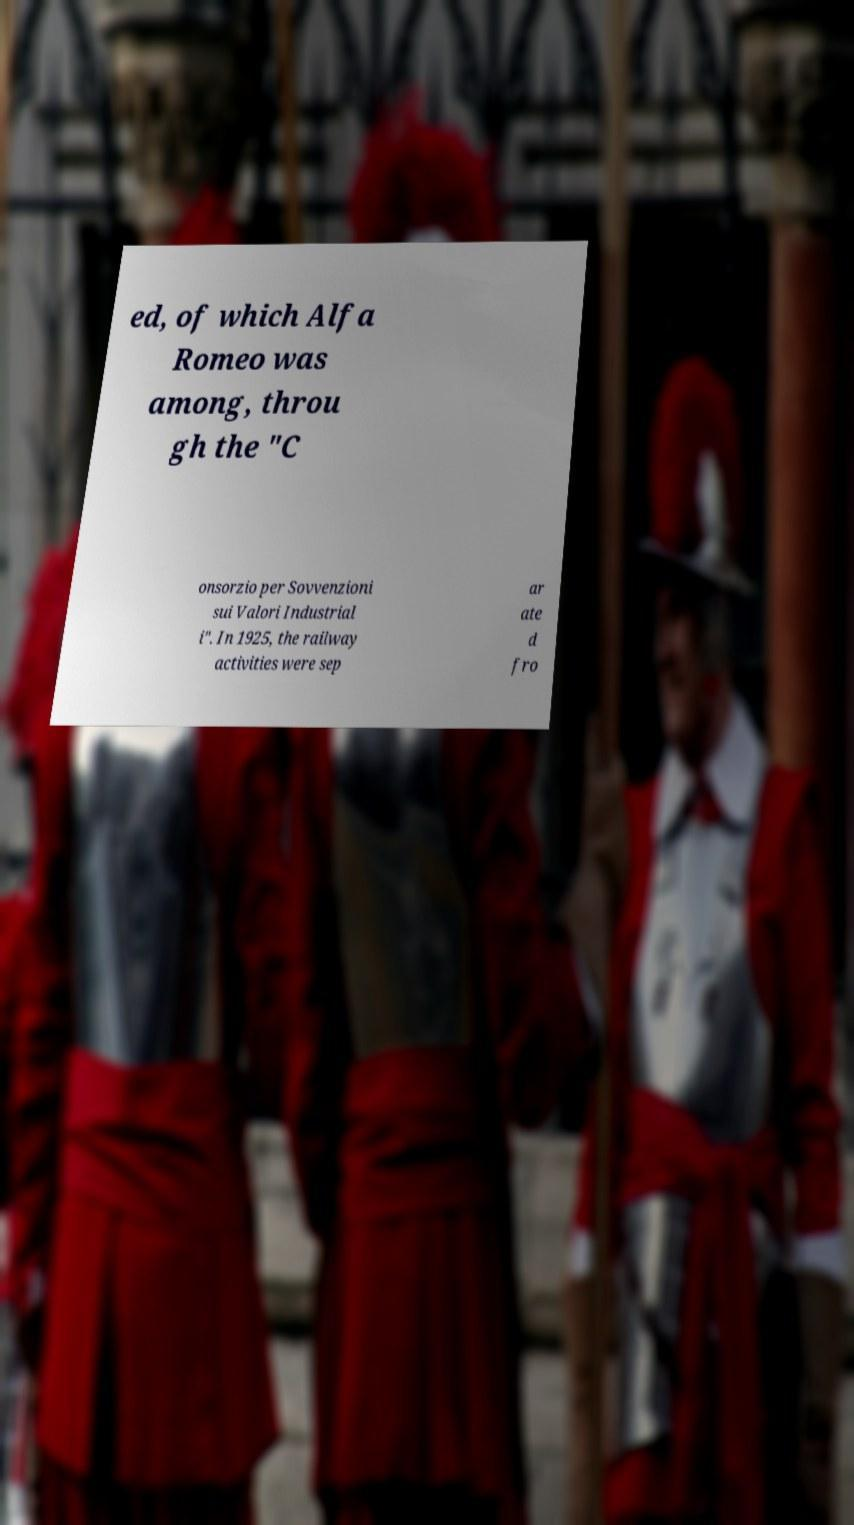For documentation purposes, I need the text within this image transcribed. Could you provide that? ed, of which Alfa Romeo was among, throu gh the "C onsorzio per Sovvenzioni sui Valori Industrial i". In 1925, the railway activities were sep ar ate d fro 